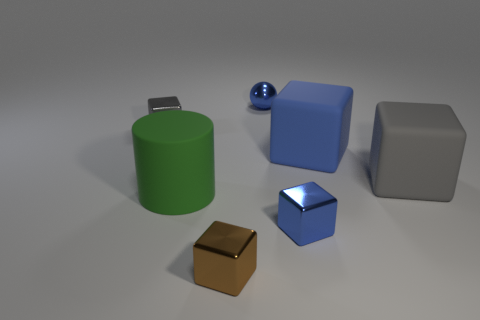What color is the other block that is the same material as the large blue cube?
Offer a very short reply. Gray. What number of small shiny balls have the same color as the rubber cylinder?
Provide a succinct answer. 0. What number of things are large cyan metal cylinders or tiny things?
Keep it short and to the point. 4. What is the shape of the blue matte thing that is the same size as the gray matte block?
Offer a very short reply. Cube. How many gray blocks are both right of the green thing and left of the ball?
Your answer should be very brief. 0. There is a tiny blue thing in front of the green cylinder; what is it made of?
Provide a succinct answer. Metal. There is a gray thing that is the same material as the small brown thing; what size is it?
Give a very brief answer. Small. Is the size of the metallic thing that is to the right of the small blue sphere the same as the metallic cube to the left of the cylinder?
Offer a terse response. Yes. What material is the brown object that is the same size as the gray metallic block?
Offer a terse response. Metal. What is the large thing that is both to the left of the big gray matte object and right of the cylinder made of?
Your answer should be compact. Rubber. 